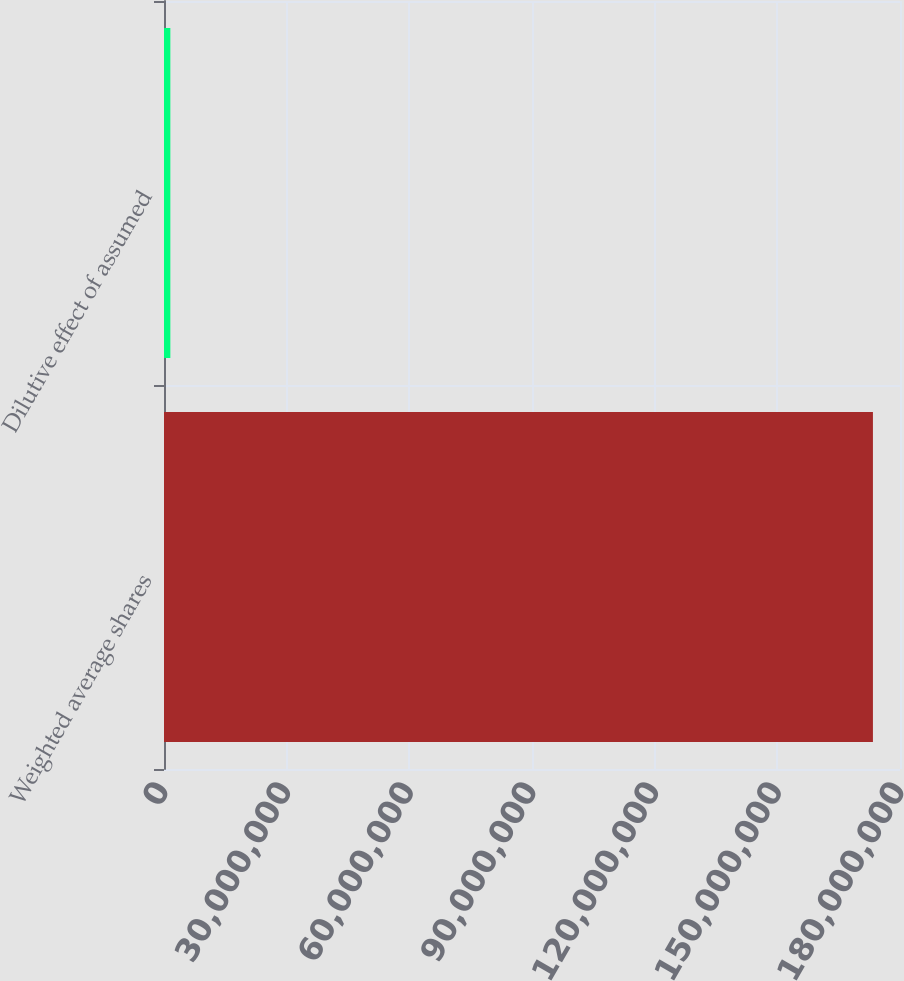<chart> <loc_0><loc_0><loc_500><loc_500><bar_chart><fcel>Weighted average shares<fcel>Dilutive effect of assumed<nl><fcel>1.73381e+08<fcel>1.553e+06<nl></chart> 